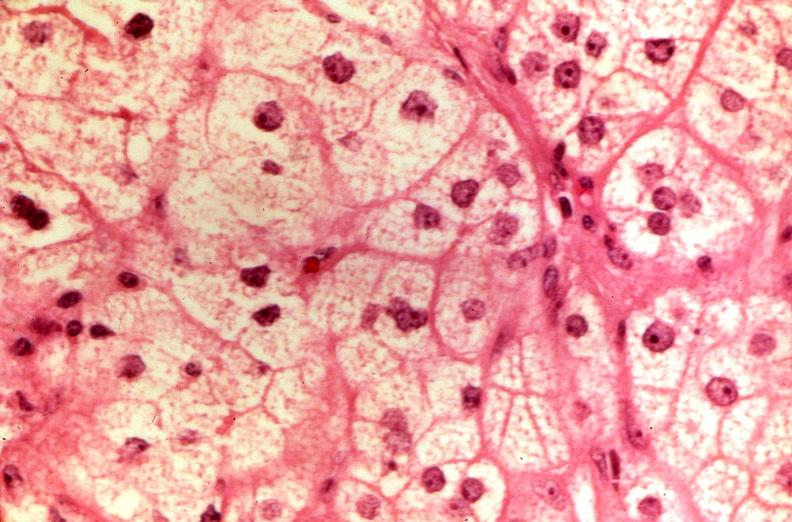does this image show pituitary, chromaphobe adenoma?
Answer the question using a single word or phrase. Yes 